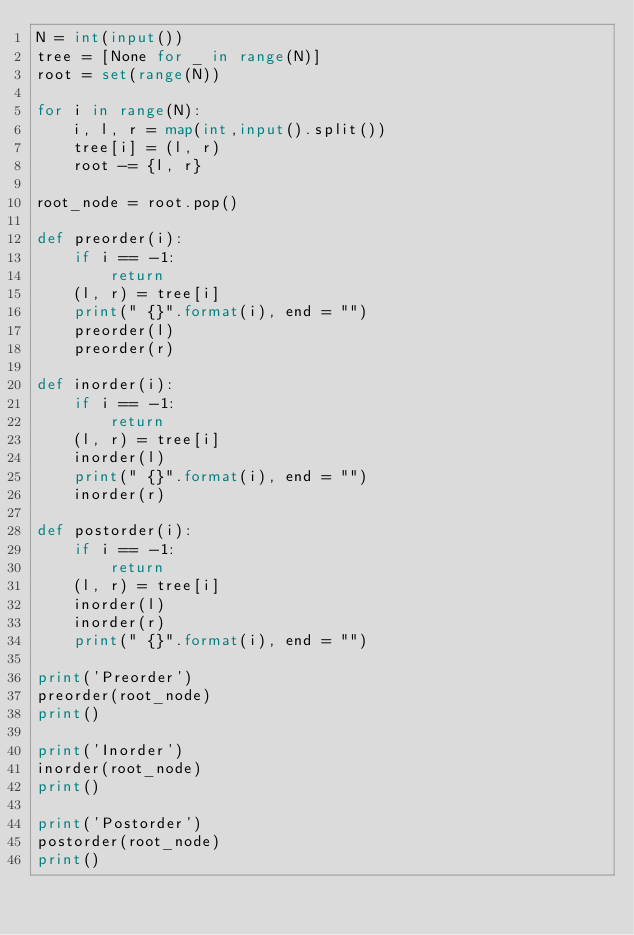Convert code to text. <code><loc_0><loc_0><loc_500><loc_500><_Python_>N = int(input())
tree = [None for _ in range(N)]
root = set(range(N))

for i in range(N):
    i, l, r = map(int,input().split())
    tree[i] = (l, r)
    root -= {l, r}

root_node = root.pop()

def preorder(i):
    if i == -1:
        return
    (l, r) = tree[i]
    print(" {}".format(i), end = "")
    preorder(l)
    preorder(r)
    
def inorder(i):
    if i == -1:
        return
    (l, r) = tree[i]
    inorder(l)
    print(" {}".format(i), end = "")
    inorder(r)
    
def postorder(i):
    if i == -1:
        return
    (l, r) = tree[i]
    inorder(l)
    inorder(r)
    print(" {}".format(i), end = "")
    
print('Preorder')
preorder(root_node)
print()

print('Inorder')
inorder(root_node)
print()

print('Postorder')
postorder(root_node)
print()</code> 